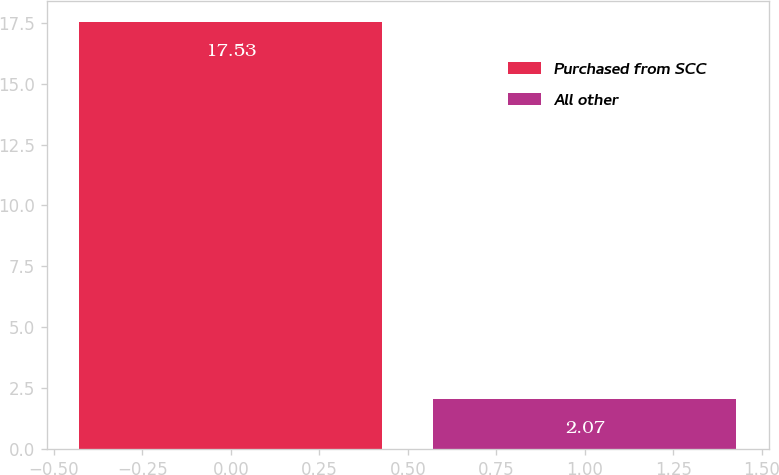<chart> <loc_0><loc_0><loc_500><loc_500><bar_chart><fcel>Purchased from SCC<fcel>All other<nl><fcel>17.53<fcel>2.07<nl></chart> 